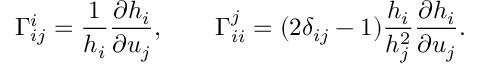Convert formula to latex. <formula><loc_0><loc_0><loc_500><loc_500>\Gamma _ { i j } ^ { i } = \frac { 1 } { h _ { i } } \frac { \partial h _ { i } } { \partial u _ { j } } , \quad \Gamma _ { i i } ^ { j } = ( 2 \delta _ { i j } - 1 ) \frac { h _ { i } } { h _ { j } ^ { 2 } } \frac { \partial h _ { i } } { \partial u _ { j } } .</formula> 